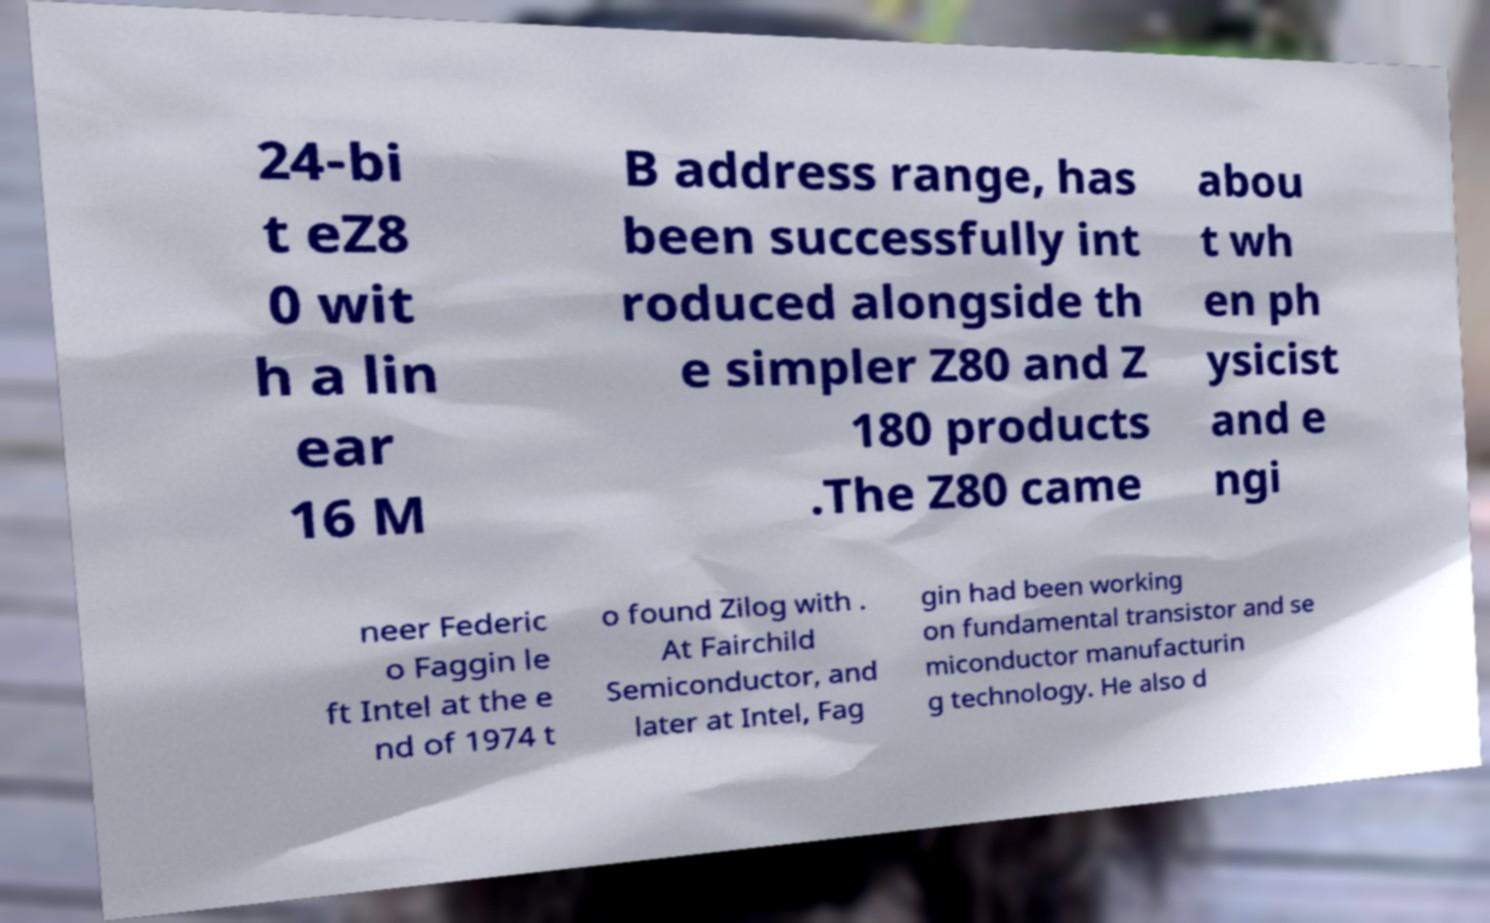Can you read and provide the text displayed in the image?This photo seems to have some interesting text. Can you extract and type it out for me? 24-bi t eZ8 0 wit h a lin ear 16 M B address range, has been successfully int roduced alongside th e simpler Z80 and Z 180 products .The Z80 came abou t wh en ph ysicist and e ngi neer Federic o Faggin le ft Intel at the e nd of 1974 t o found Zilog with . At Fairchild Semiconductor, and later at Intel, Fag gin had been working on fundamental transistor and se miconductor manufacturin g technology. He also d 